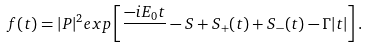Convert formula to latex. <formula><loc_0><loc_0><loc_500><loc_500>f ( t ) = | P | ^ { 2 } e x p \left [ \frac { - i E _ { 0 } t } { } - S + S _ { + } ( t ) + S _ { - } ( t ) - \Gamma | t | \right ] .</formula> 